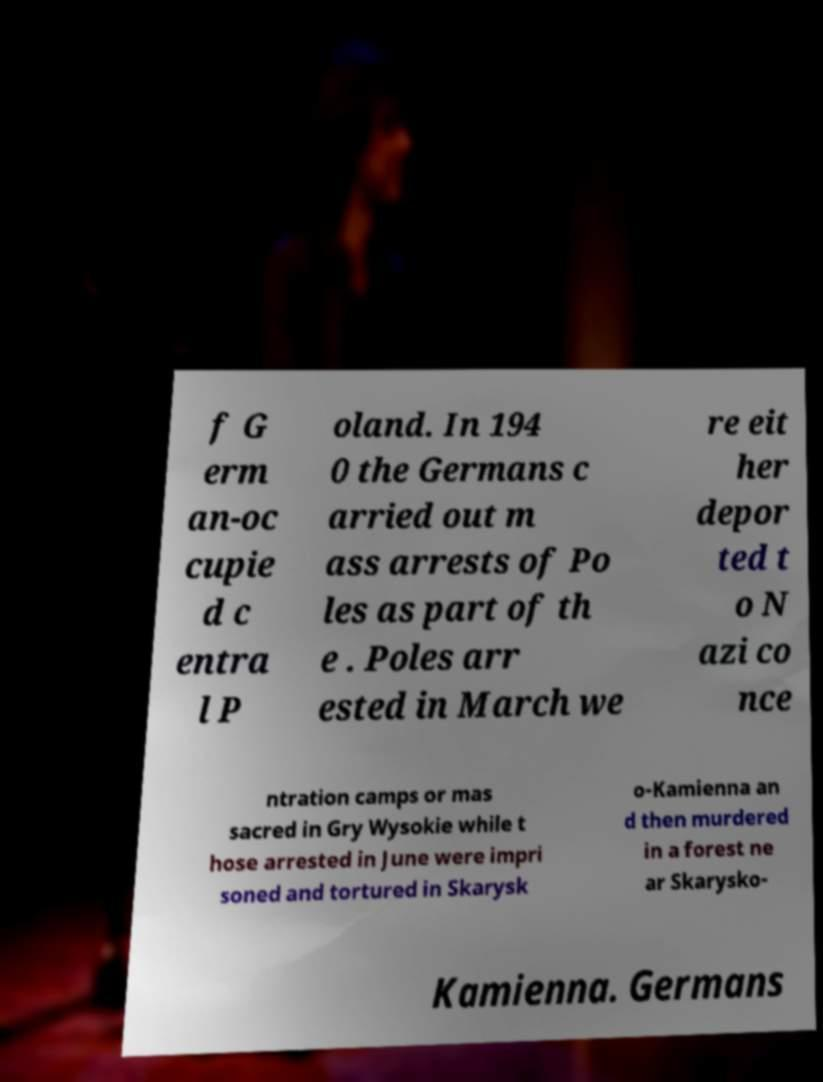Please identify and transcribe the text found in this image. f G erm an-oc cupie d c entra l P oland. In 194 0 the Germans c arried out m ass arrests of Po les as part of th e . Poles arr ested in March we re eit her depor ted t o N azi co nce ntration camps or mas sacred in Gry Wysokie while t hose arrested in June were impri soned and tortured in Skarysk o-Kamienna an d then murdered in a forest ne ar Skarysko- Kamienna. Germans 